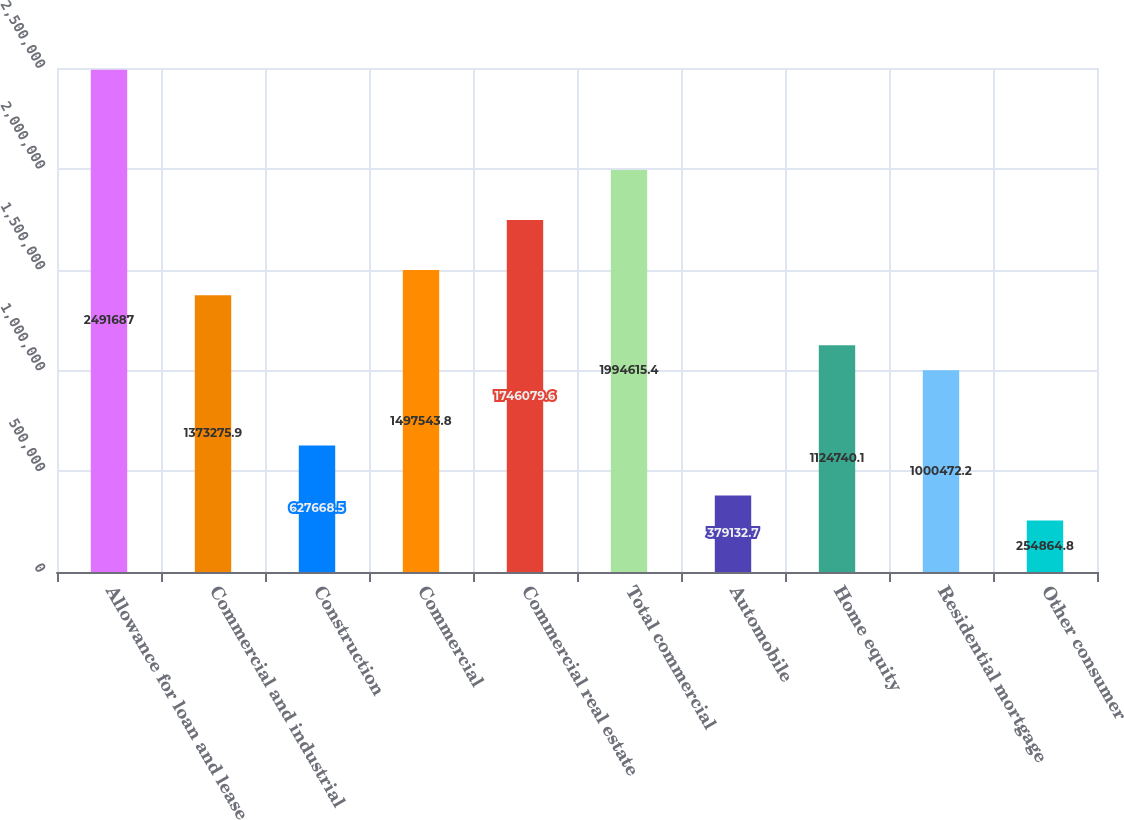Convert chart. <chart><loc_0><loc_0><loc_500><loc_500><bar_chart><fcel>Allowance for loan and lease<fcel>Commercial and industrial<fcel>Construction<fcel>Commercial<fcel>Commercial real estate<fcel>Total commercial<fcel>Automobile<fcel>Home equity<fcel>Residential mortgage<fcel>Other consumer<nl><fcel>2.49169e+06<fcel>1.37328e+06<fcel>627668<fcel>1.49754e+06<fcel>1.74608e+06<fcel>1.99462e+06<fcel>379133<fcel>1.12474e+06<fcel>1.00047e+06<fcel>254865<nl></chart> 